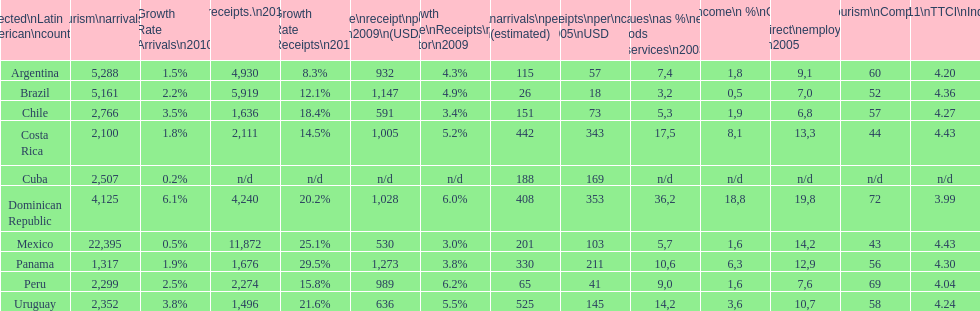How many international tourism arrivals in 2010(x1000) did mexico have? 22,395. 